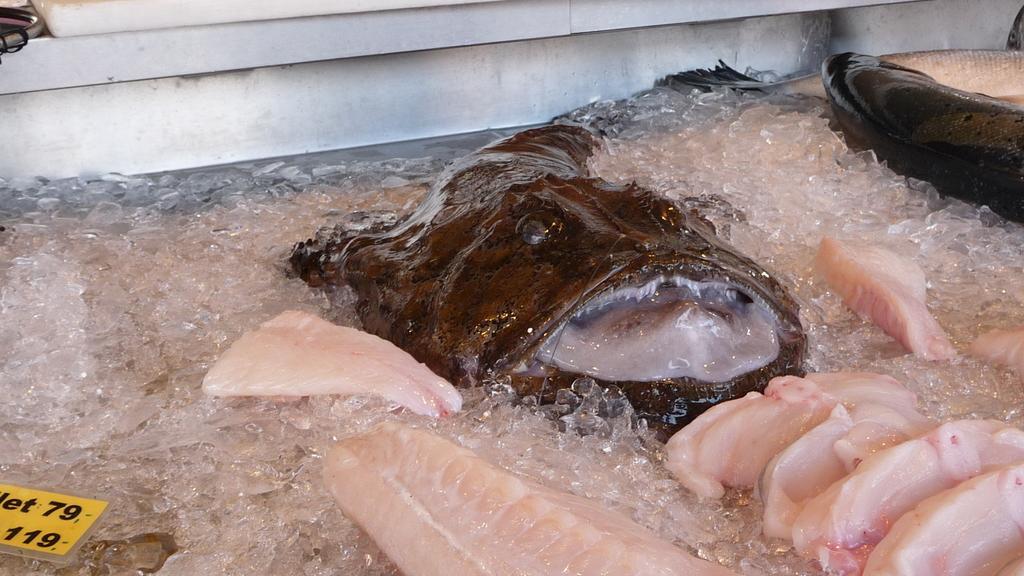Describe this image in one or two sentences. In this picture there is a fish in the center of the image and there is another fish in the top right side of the image, there is ice around the area of the image. 